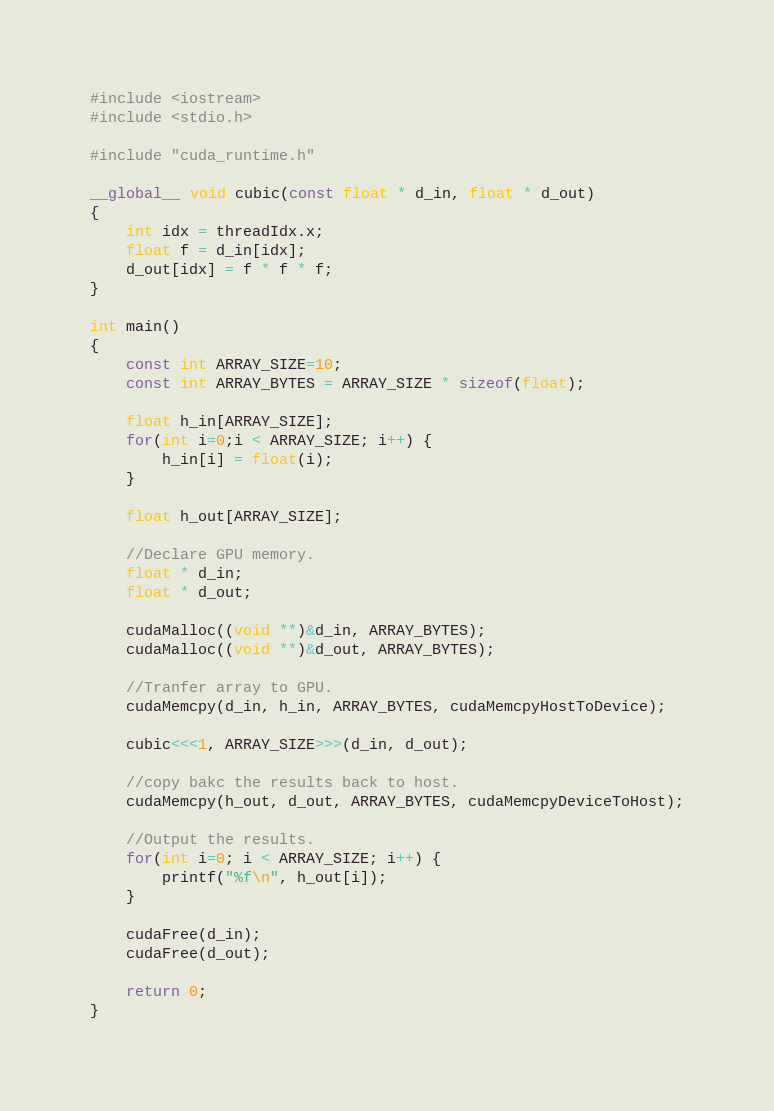Convert code to text. <code><loc_0><loc_0><loc_500><loc_500><_Cuda_>#include <iostream>
#include <stdio.h>

#include "cuda_runtime.h"

__global__ void cubic(const float * d_in, float * d_out)
{
    int idx = threadIdx.x;
    float f = d_in[idx];
    d_out[idx] = f * f * f;
}

int main()
{
    const int ARRAY_SIZE=10;
    const int ARRAY_BYTES = ARRAY_SIZE * sizeof(float);

    float h_in[ARRAY_SIZE];
    for(int i=0;i < ARRAY_SIZE; i++) {
        h_in[i] = float(i);
    }

    float h_out[ARRAY_SIZE];
    
    //Declare GPU memory.
    float * d_in;
    float * d_out;
    
    cudaMalloc((void **)&d_in, ARRAY_BYTES);
    cudaMalloc((void **)&d_out, ARRAY_BYTES);

    //Tranfer array to GPU.
    cudaMemcpy(d_in, h_in, ARRAY_BYTES, cudaMemcpyHostToDevice);

    cubic<<<1, ARRAY_SIZE>>>(d_in, d_out);

    //copy bakc the results back to host.
    cudaMemcpy(h_out, d_out, ARRAY_BYTES, cudaMemcpyDeviceToHost);

    //Output the results.
    for(int i=0; i < ARRAY_SIZE; i++) {
        printf("%f\n", h_out[i]);
    }

    cudaFree(d_in);
    cudaFree(d_out);

    return 0;
}
</code> 